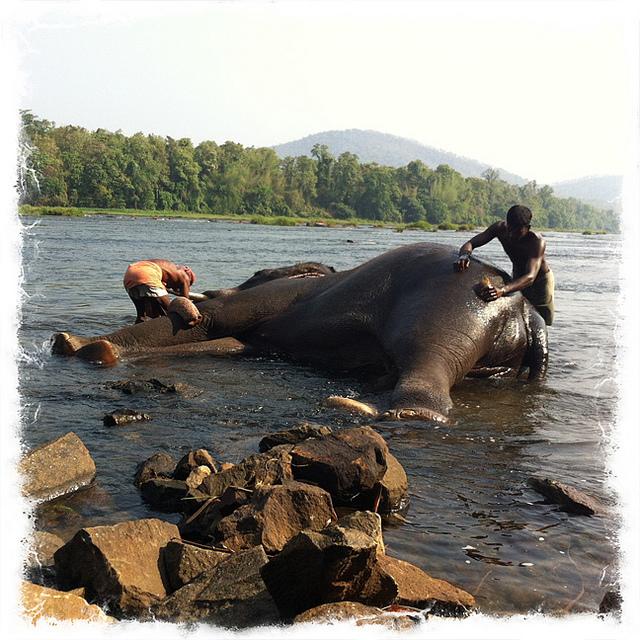What animal are the people working on?
Concise answer only. Elephant. What color is the elephant?
Write a very short answer. Gray. Is the trunk of the elephant showing?
Write a very short answer. No. 